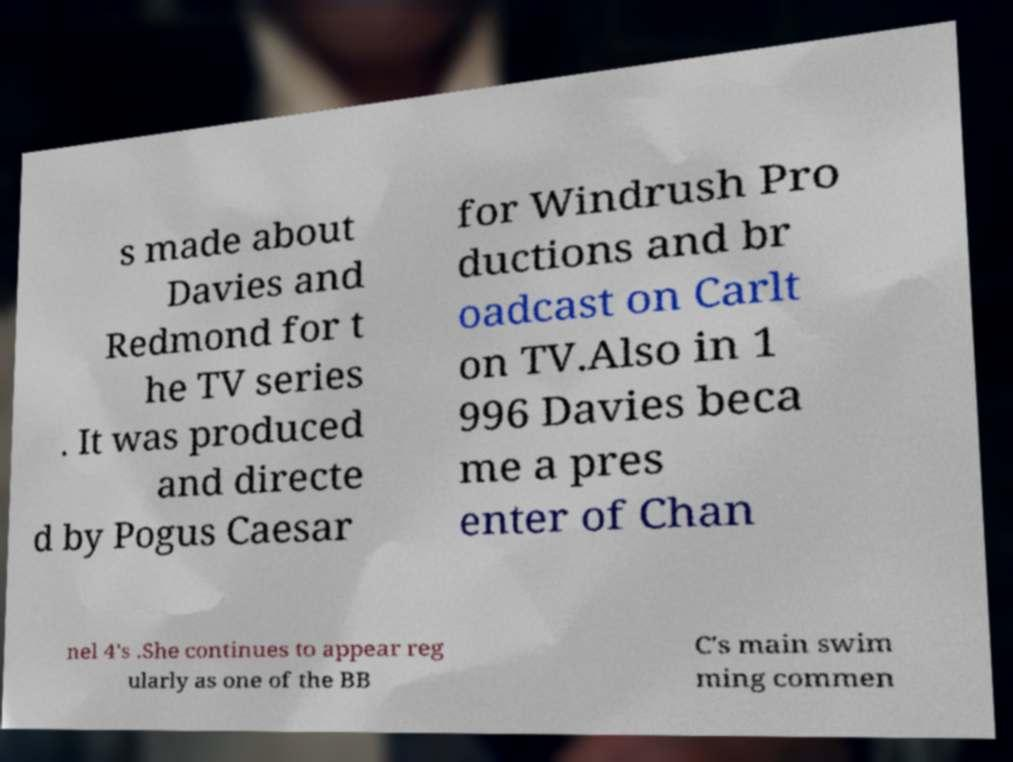I need the written content from this picture converted into text. Can you do that? s made about Davies and Redmond for t he TV series . It was produced and directe d by Pogus Caesar for Windrush Pro ductions and br oadcast on Carlt on TV.Also in 1 996 Davies beca me a pres enter of Chan nel 4's .She continues to appear reg ularly as one of the BB C's main swim ming commen 